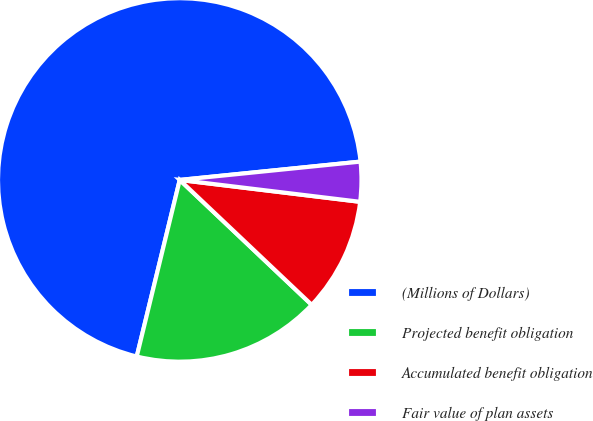Convert chart to OTSL. <chart><loc_0><loc_0><loc_500><loc_500><pie_chart><fcel>(Millions of Dollars)<fcel>Projected benefit obligation<fcel>Accumulated benefit obligation<fcel>Fair value of plan assets<nl><fcel>69.59%<fcel>16.74%<fcel>10.14%<fcel>3.53%<nl></chart> 